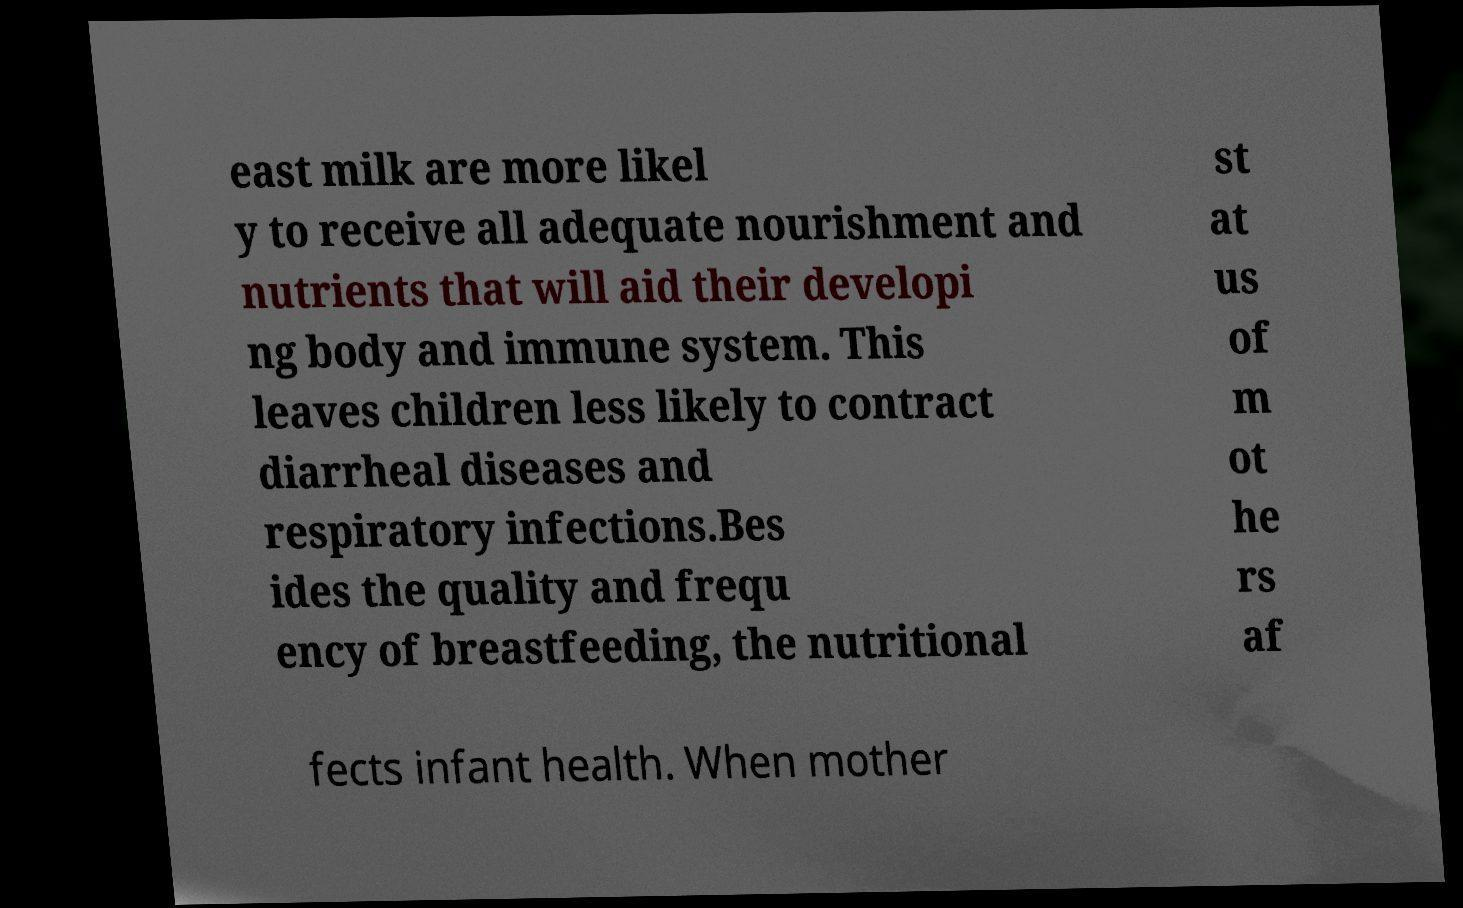Please identify and transcribe the text found in this image. east milk are more likel y to receive all adequate nourishment and nutrients that will aid their developi ng body and immune system. This leaves children less likely to contract diarrheal diseases and respiratory infections.Bes ides the quality and frequ ency of breastfeeding, the nutritional st at us of m ot he rs af fects infant health. When mother 